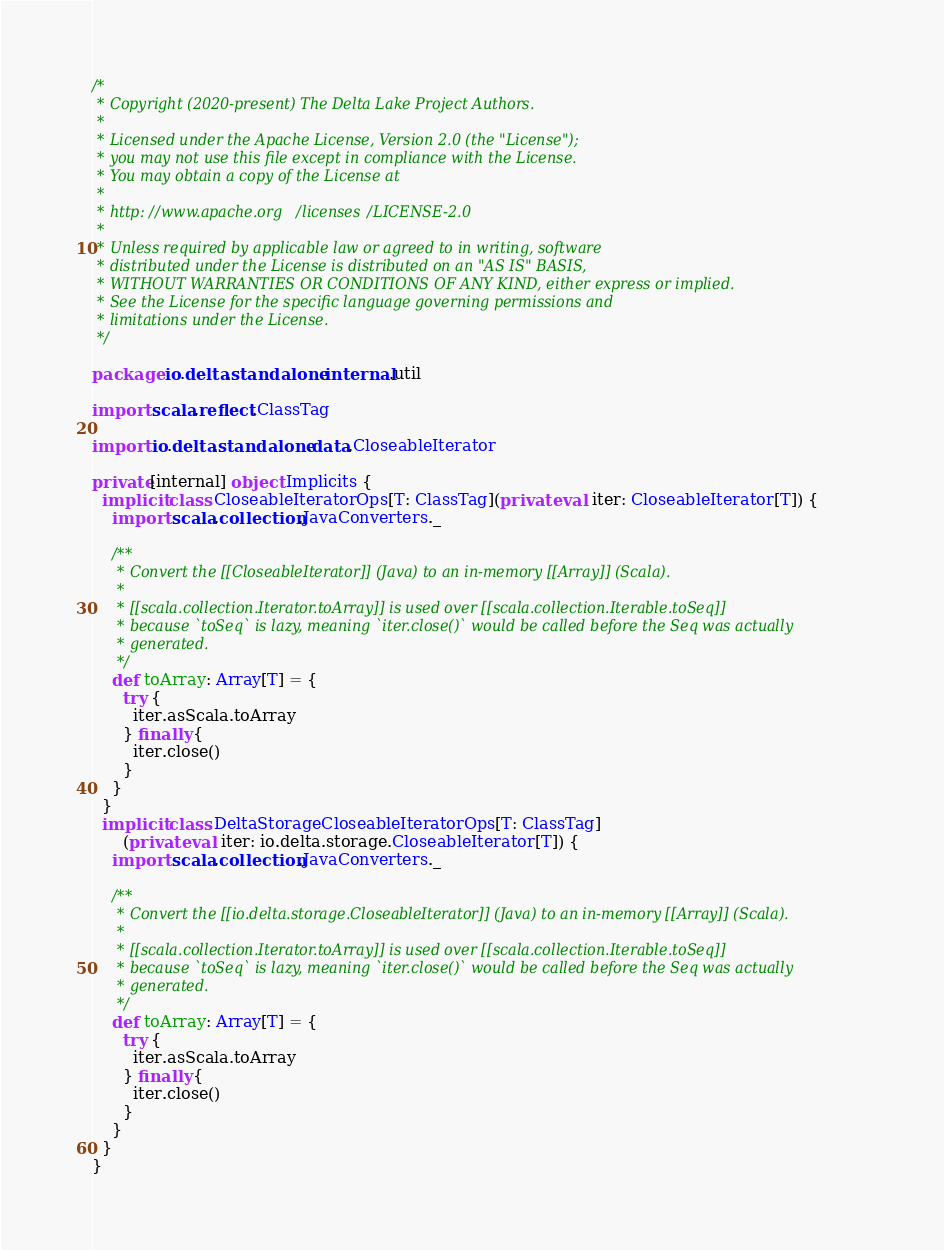Convert code to text. <code><loc_0><loc_0><loc_500><loc_500><_Scala_>/*
 * Copyright (2020-present) The Delta Lake Project Authors.
 *
 * Licensed under the Apache License, Version 2.0 (the "License");
 * you may not use this file except in compliance with the License.
 * You may obtain a copy of the License at
 *
 * http://www.apache.org/licenses/LICENSE-2.0
 *
 * Unless required by applicable law or agreed to in writing, software
 * distributed under the License is distributed on an "AS IS" BASIS,
 * WITHOUT WARRANTIES OR CONDITIONS OF ANY KIND, either express or implied.
 * See the License for the specific language governing permissions and
 * limitations under the License.
 */

package io.delta.standalone.internal.util

import scala.reflect.ClassTag

import io.delta.standalone.data.CloseableIterator

private[internal] object Implicits {
  implicit class CloseableIteratorOps[T: ClassTag](private val iter: CloseableIterator[T]) {
    import scala.collection.JavaConverters._

    /**
     * Convert the [[CloseableIterator]] (Java) to an in-memory [[Array]] (Scala).
     *
     * [[scala.collection.Iterator.toArray]] is used over [[scala.collection.Iterable.toSeq]]
     * because `toSeq` is lazy, meaning `iter.close()` would be called before the Seq was actually
     * generated.
     */
    def toArray: Array[T] = {
      try {
        iter.asScala.toArray
      } finally {
        iter.close()
      }
    }
  }
  implicit class DeltaStorageCloseableIteratorOps[T: ClassTag]
      (private val iter: io.delta.storage.CloseableIterator[T]) {
    import scala.collection.JavaConverters._

    /**
     * Convert the [[io.delta.storage.CloseableIterator]] (Java) to an in-memory [[Array]] (Scala).
     *
     * [[scala.collection.Iterator.toArray]] is used over [[scala.collection.Iterable.toSeq]]
     * because `toSeq` is lazy, meaning `iter.close()` would be called before the Seq was actually
     * generated.
     */
    def toArray: Array[T] = {
      try {
        iter.asScala.toArray
      } finally {
        iter.close()
      }
    }
  }
}
</code> 